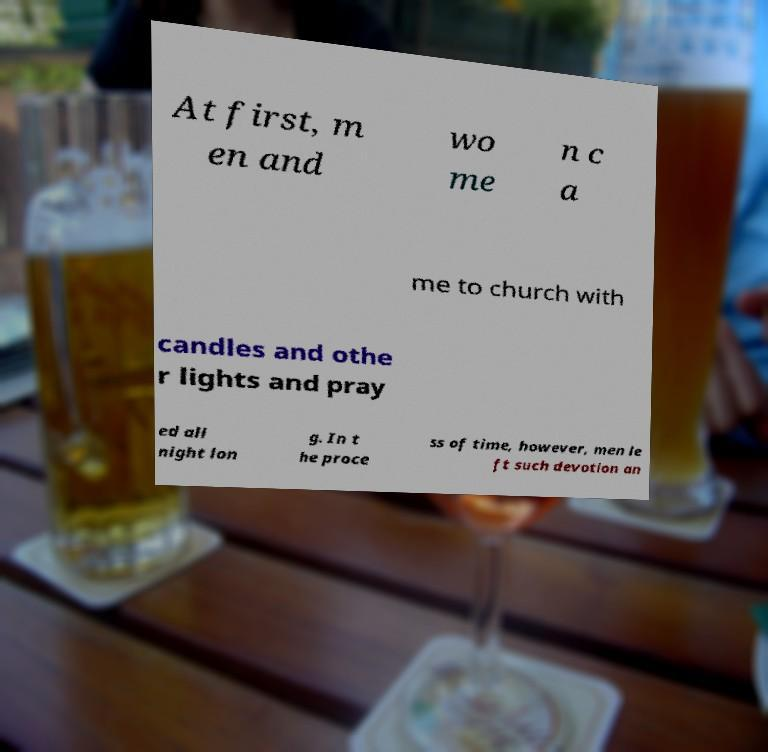For documentation purposes, I need the text within this image transcribed. Could you provide that? At first, m en and wo me n c a me to church with candles and othe r lights and pray ed all night lon g. In t he proce ss of time, however, men le ft such devotion an 